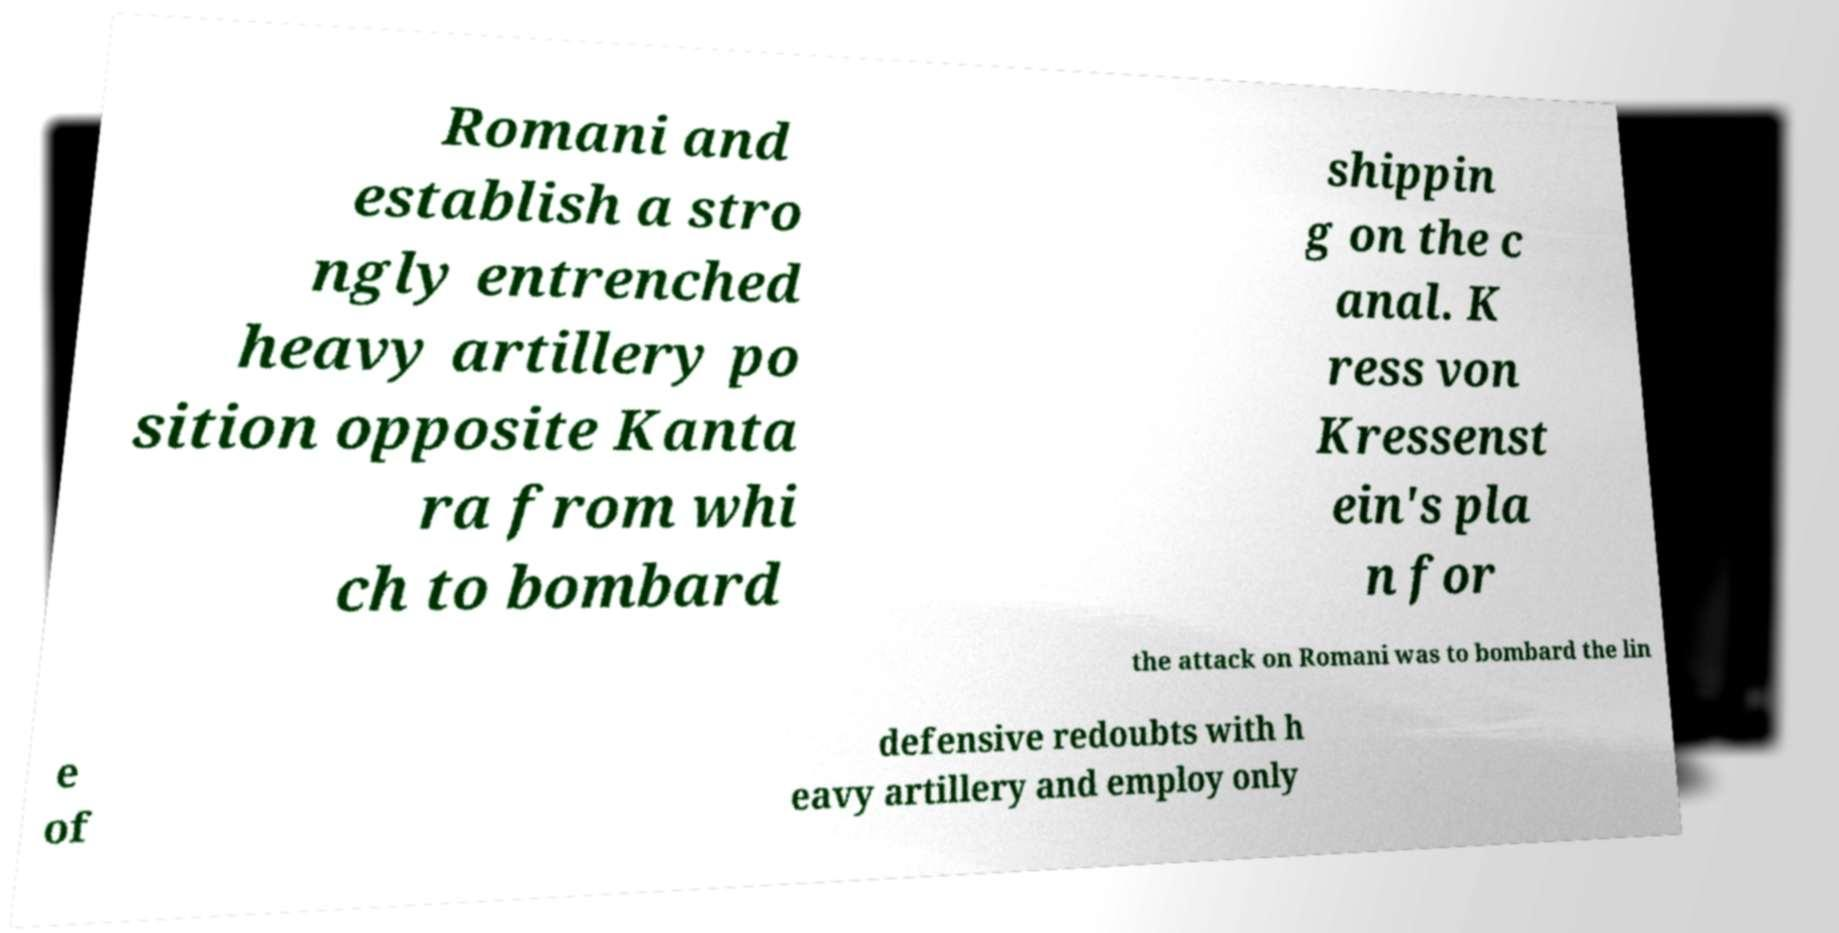There's text embedded in this image that I need extracted. Can you transcribe it verbatim? Romani and establish a stro ngly entrenched heavy artillery po sition opposite Kanta ra from whi ch to bombard shippin g on the c anal. K ress von Kressenst ein's pla n for the attack on Romani was to bombard the lin e of defensive redoubts with h eavy artillery and employ only 